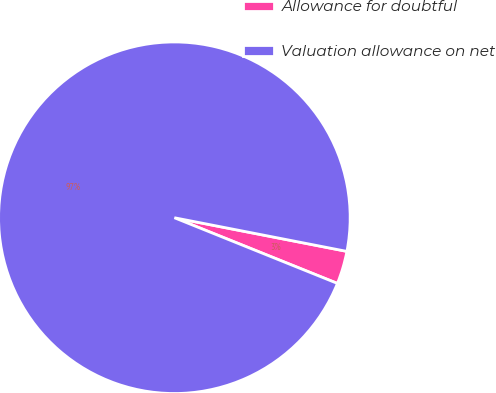Convert chart. <chart><loc_0><loc_0><loc_500><loc_500><pie_chart><fcel>Allowance for doubtful<fcel>Valuation allowance on net<nl><fcel>3.03%<fcel>96.97%<nl></chart> 